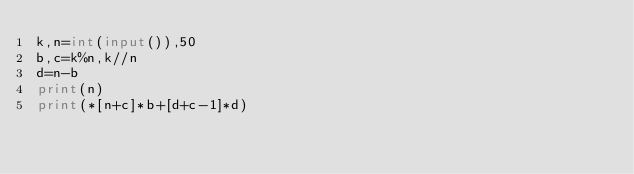Convert code to text. <code><loc_0><loc_0><loc_500><loc_500><_Python_>k,n=int(input()),50
b,c=k%n,k//n
d=n-b
print(n)
print(*[n+c]*b+[d+c-1]*d)</code> 